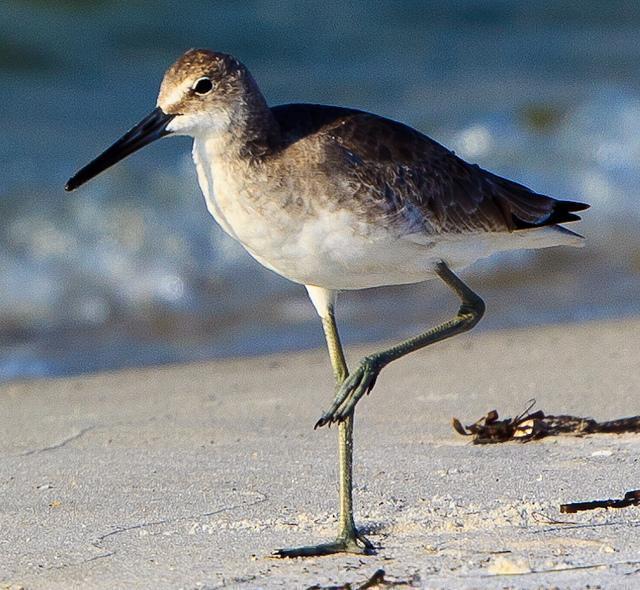How many people are on the elephant on the right?
Give a very brief answer. 0. 